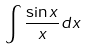Convert formula to latex. <formula><loc_0><loc_0><loc_500><loc_500>\int \frac { \sin x } { x } d x</formula> 